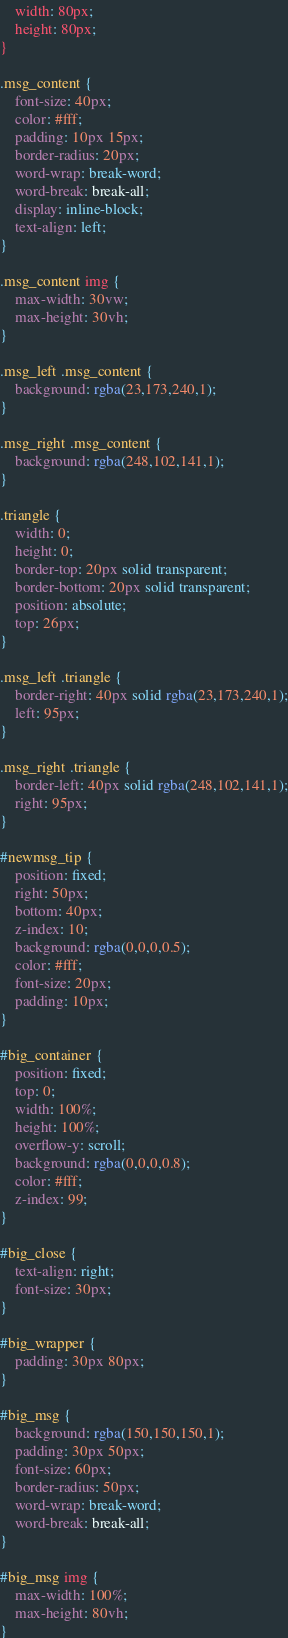Convert code to text. <code><loc_0><loc_0><loc_500><loc_500><_CSS_>    width: 80px;
    height: 80px;
}

.msg_content {
    font-size: 40px;
    color: #fff;
    padding: 10px 15px;
    border-radius: 20px;
    word-wrap: break-word;
    word-break: break-all;
    display: inline-block;
    text-align: left;
}

.msg_content img {
    max-width: 30vw;
    max-height: 30vh;
}

.msg_left .msg_content {
    background: rgba(23,173,240,1);
}

.msg_right .msg_content {
    background: rgba(248,102,141,1);
}

.triangle {
    width: 0;
    height: 0;
    border-top: 20px solid transparent;
    border-bottom: 20px solid transparent;
    position: absolute;
    top: 26px;
}

.msg_left .triangle {
    border-right: 40px solid rgba(23,173,240,1);
    left: 95px;
}

.msg_right .triangle {
    border-left: 40px solid rgba(248,102,141,1);
    right: 95px;
}

#newmsg_tip {
    position: fixed;
    right: 50px;
    bottom: 40px;
    z-index: 10;
    background: rgba(0,0,0,0.5);
    color: #fff;
    font-size: 20px;
    padding: 10px;
}

#big_container {
    position: fixed;
    top: 0;
    width: 100%;
    height: 100%;
    overflow-y: scroll;
    background: rgba(0,0,0,0.8);
    color: #fff;
    z-index: 99;
}

#big_close {
    text-align: right;
    font-size: 30px;
}

#big_wrapper {
    padding: 30px 80px;
}

#big_msg {
    background: rgba(150,150,150,1);
    padding: 30px 50px;
    font-size: 60px;
    border-radius: 50px;
    word-wrap: break-word;
    word-break: break-all;
}

#big_msg img {
    max-width: 100%;
    max-height: 80vh;
}</code> 